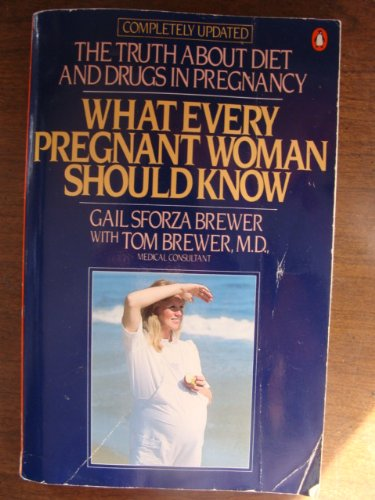Is this a pharmaceutical book? No, this book is not strictly a pharmaceutical book; rather, it integrates various aspects of medical care and nutritional advice vital for pregnant women. 